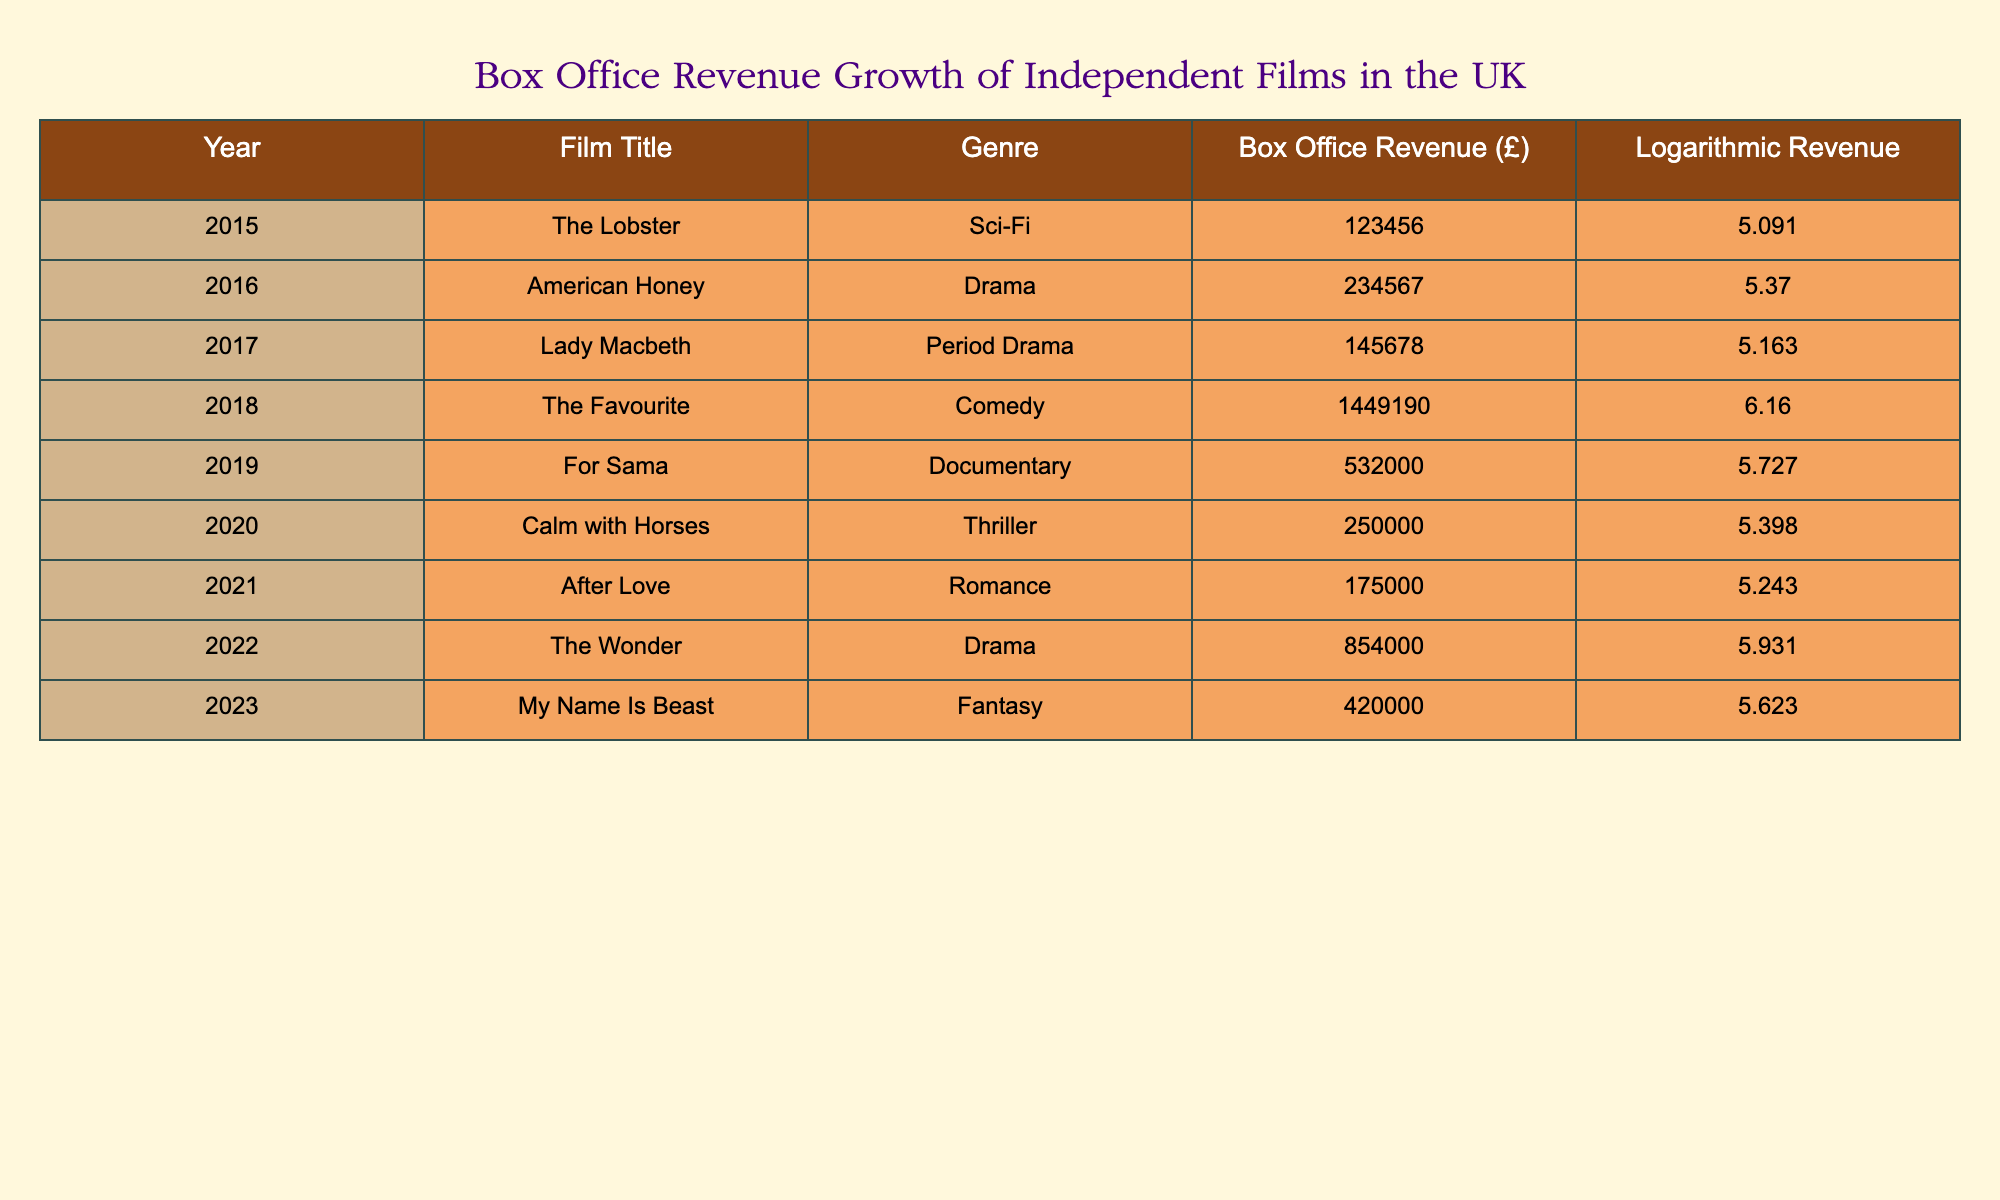What was the box office revenue for "The Favourite"? The box office revenue for "The Favourite" in 2018 is listed in the table as £1,449,190.
Answer: £1,449,190 In which year was the film "American Honey" released? The table indicates that "American Honey" was released in 2016, as shown in the Year column next to the film title.
Answer: 2016 Which independent film had the highest box office revenue? "The Favourite" has the highest box office revenue with £1,449,190. This can be confirmed by scanning the Box Office Revenue column and identifying the maximum value.
Answer: £1,449,190 What is the average box office revenue of the films listed from 2015 to 2023? The total box office revenues of the films are £123,456 + £234,567 + £145,678 + £1,449,190 + £532,000 + £250,000 + £175,000 + £854,000 + £420,000 = £3,734,891. There are 9 films, so the average is £3,734,891 / 9 ≈ £414,988.
Answer: £414,988 Did "For Sama" make more money than "Calm with Horses"? "For Sama" had a box office revenue of £532,000 and "Calm with Horses" had £250,000. Since £532,000 is greater than £250,000, the statement is true.
Answer: Yes Which genre had the highest box office revenue in a single release? The Comedy genre had "The Favourite" with the highest revenue of £1,449,190 in a single release. This can be determined by looking at the Genre column combined with the Box Office Revenue column.
Answer: Comedy What is the total box office revenue for films released in 2020 and 2021? The total revenue from 2020 ("Calm with Horses" - £250,000) and 2021 ("After Love" - £175,000) is calculated as £250,000 + £175,000 = £425,000.
Answer: £425,000 Was the logarithmic revenue for "Lady Macbeth" higher than for "After Love"? "Lady Macbeth" has a logarithmic revenue of 5.163 while "After Love" has 5.243. Since 5.163 is less than 5.243, the statement is false.
Answer: No 